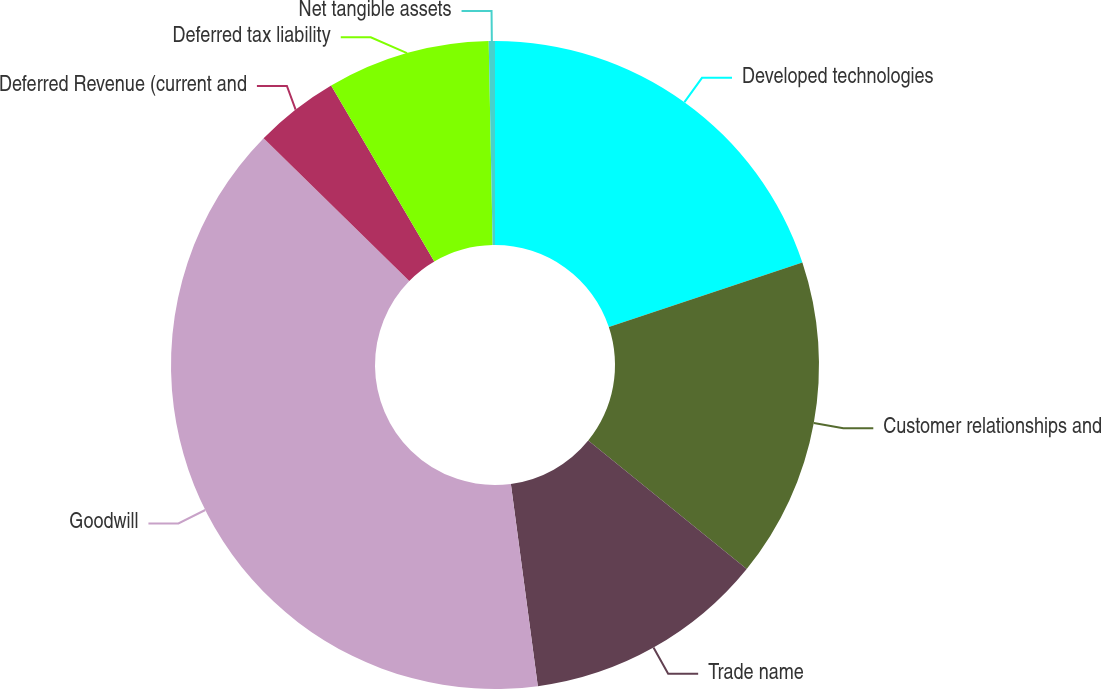<chart> <loc_0><loc_0><loc_500><loc_500><pie_chart><fcel>Developed technologies<fcel>Customer relationships and<fcel>Trade name<fcel>Goodwill<fcel>Deferred Revenue (current and<fcel>Deferred tax liability<fcel>Net tangible assets<nl><fcel>19.88%<fcel>15.96%<fcel>12.05%<fcel>39.45%<fcel>4.22%<fcel>8.13%<fcel>0.31%<nl></chart> 